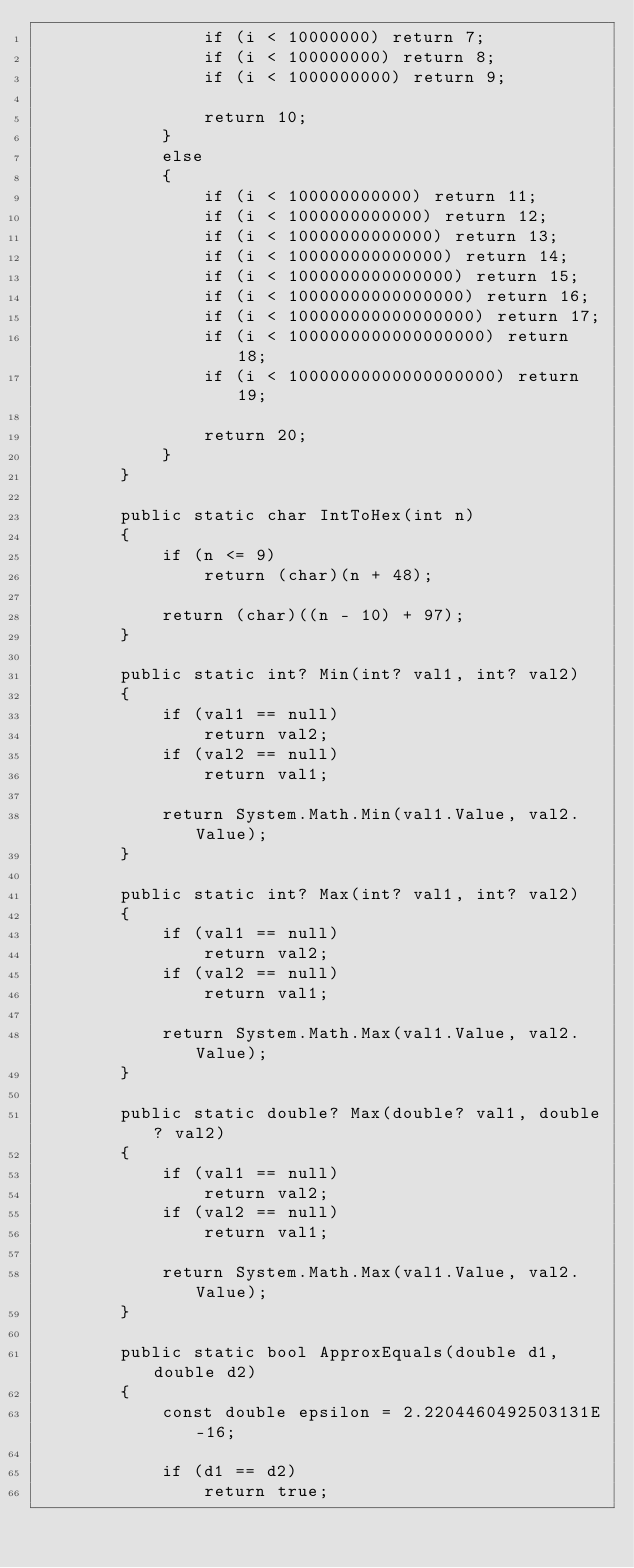<code> <loc_0><loc_0><loc_500><loc_500><_C#_>                if (i < 10000000) return 7;
                if (i < 100000000) return 8;
                if (i < 1000000000) return 9;

                return 10;
            }
            else
            {
                if (i < 100000000000) return 11;
                if (i < 1000000000000) return 12;
                if (i < 10000000000000) return 13;
                if (i < 100000000000000) return 14;
                if (i < 1000000000000000) return 15;
                if (i < 10000000000000000) return 16;
                if (i < 100000000000000000) return 17;
                if (i < 1000000000000000000) return 18;
                if (i < 10000000000000000000) return 19;

                return 20;
            }
        }

        public static char IntToHex(int n)
        {
            if (n <= 9)
                return (char)(n + 48);

            return (char)((n - 10) + 97);
        }

        public static int? Min(int? val1, int? val2)
        {
            if (val1 == null)
                return val2;
            if (val2 == null)
                return val1;

            return System.Math.Min(val1.Value, val2.Value);
        }

        public static int? Max(int? val1, int? val2)
        {
            if (val1 == null)
                return val2;
            if (val2 == null)
                return val1;

            return System.Math.Max(val1.Value, val2.Value);
        }

        public static double? Max(double? val1, double? val2)
        {
            if (val1 == null)
                return val2;
            if (val2 == null)
                return val1;

            return System.Math.Max(val1.Value, val2.Value);
        }

        public static bool ApproxEquals(double d1, double d2)
        {
            const double epsilon = 2.2204460492503131E-16;

            if (d1 == d2)
                return true;
</code> 